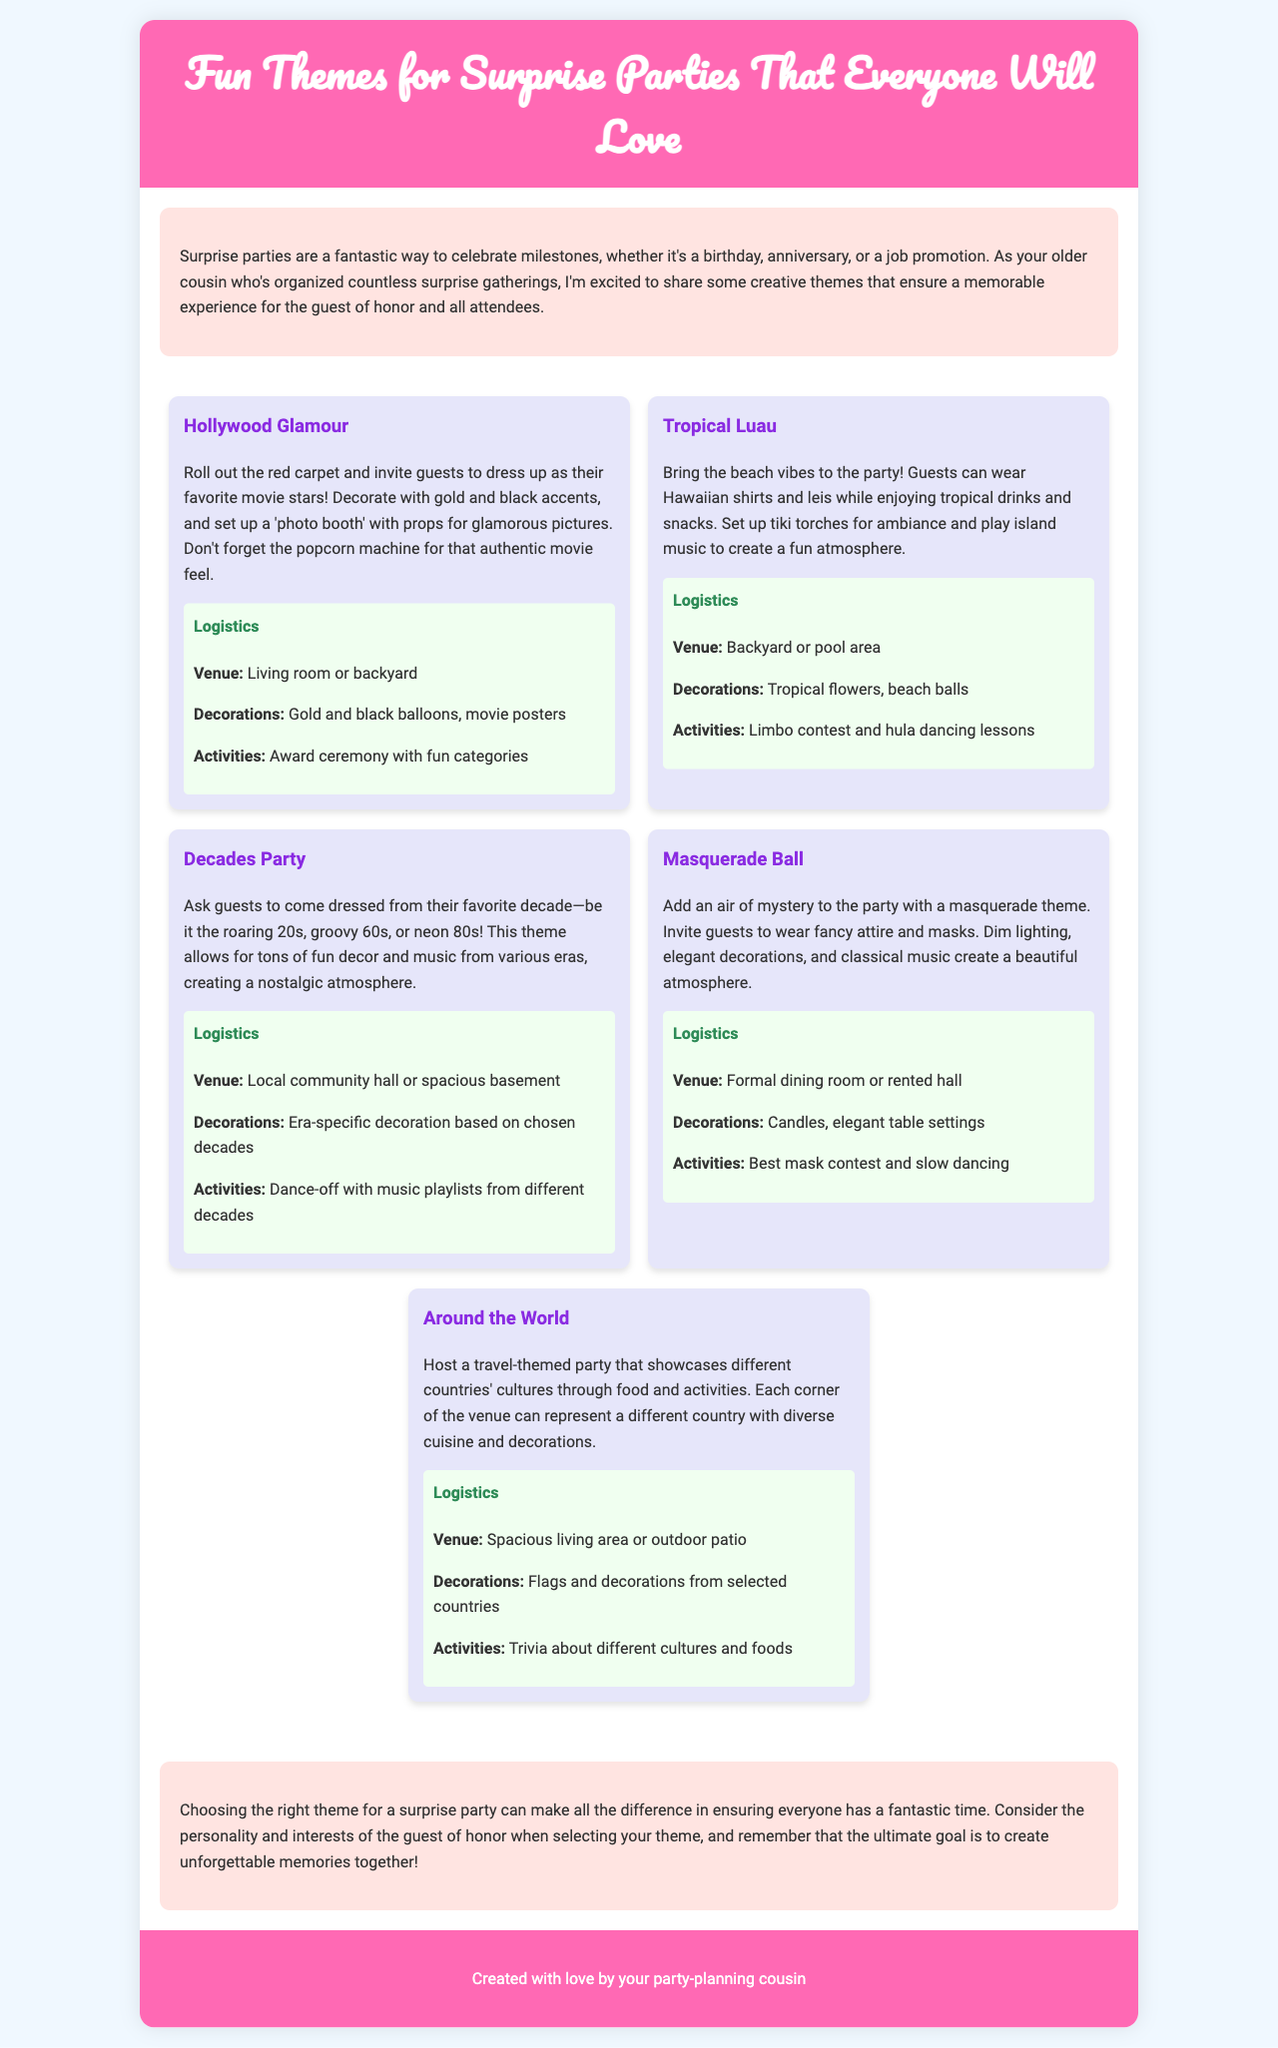What is the theme of the first party? The first party theme mentioned in the document is "Hollywood Glamour."
Answer: Hollywood Glamour What activities are suggested for the Tropical Luau theme? The document suggests a limbo contest and hula dancing lessons as activities for the Tropical Luau theme.
Answer: Limbo contest and hula dancing lessons How many themes are presented in the brochure? The document presents a total of five different themes for surprise parties.
Answer: Five What color scheme is recommended for the Masquerade Ball? The recommended color scheme for the Masquerade Ball involves dim lighting and elegant decorations, with a focus on a formal aesthetic.
Answer: Elegant decorations Which venue is suggested for the Decades Party? The suggested venue for the Decades Party is a local community hall or spacious basement.
Answer: Local community hall or spacious basement What kind of music should be played at the Tropical Luau? The document indicates that island music should be played to create a fun atmosphere at the Tropical Luau.
Answer: Island music What is the goal of choosing a theme for a surprise party? The goal of choosing a theme for a surprise party is to create unforgettable memories together.
Answer: Create unforgettable memories together What type of decoration is suggested for the "Around the World" theme? The suggested decoration for the "Around the World" theme includes flags and decorations from selected countries.
Answer: Flags and decorations from selected countries 